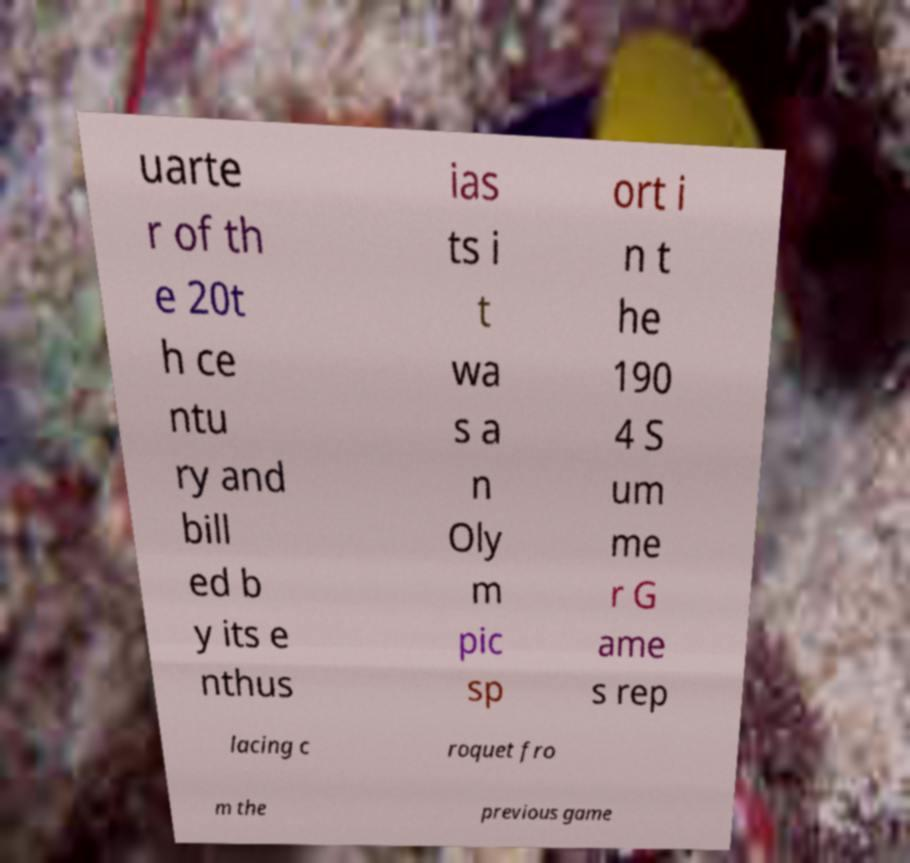What messages or text are displayed in this image? I need them in a readable, typed format. uarte r of th e 20t h ce ntu ry and bill ed b y its e nthus ias ts i t wa s a n Oly m pic sp ort i n t he 190 4 S um me r G ame s rep lacing c roquet fro m the previous game 